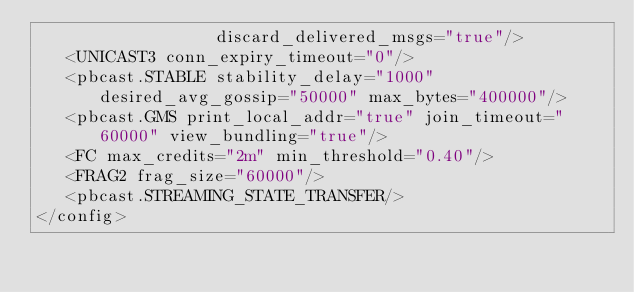<code> <loc_0><loc_0><loc_500><loc_500><_XML_>                  discard_delivered_msgs="true"/>
   <UNICAST3 conn_expiry_timeout="0"/>
   <pbcast.STABLE stability_delay="1000" desired_avg_gossip="50000" max_bytes="400000"/>
   <pbcast.GMS print_local_addr="true" join_timeout="60000" view_bundling="true"/>
   <FC max_credits="2m" min_threshold="0.40"/>
   <FRAG2 frag_size="60000"/>
   <pbcast.STREAMING_STATE_TRANSFER/>
</config>
</code> 